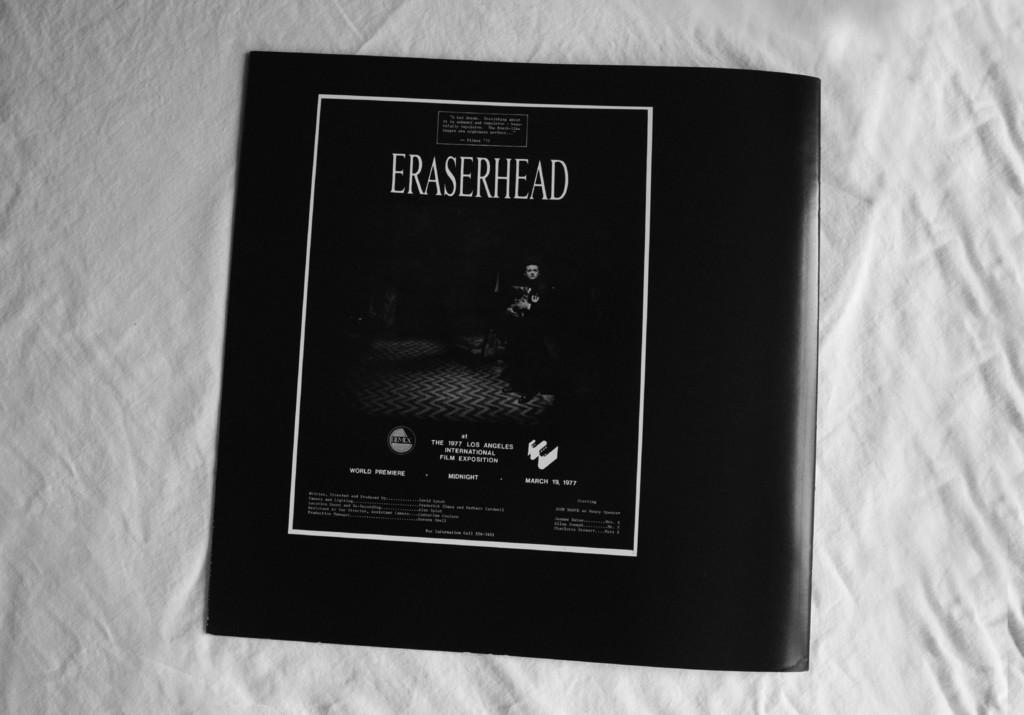<image>
Present a compact description of the photo's key features. A black pamphlet of Eraserhead placed on a white sheet. 